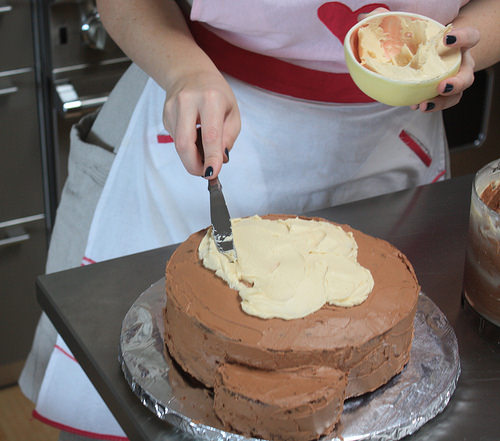<image>
Is the woman behind the cake? Yes. From this viewpoint, the woman is positioned behind the cake, with the cake partially or fully occluding the woman. 